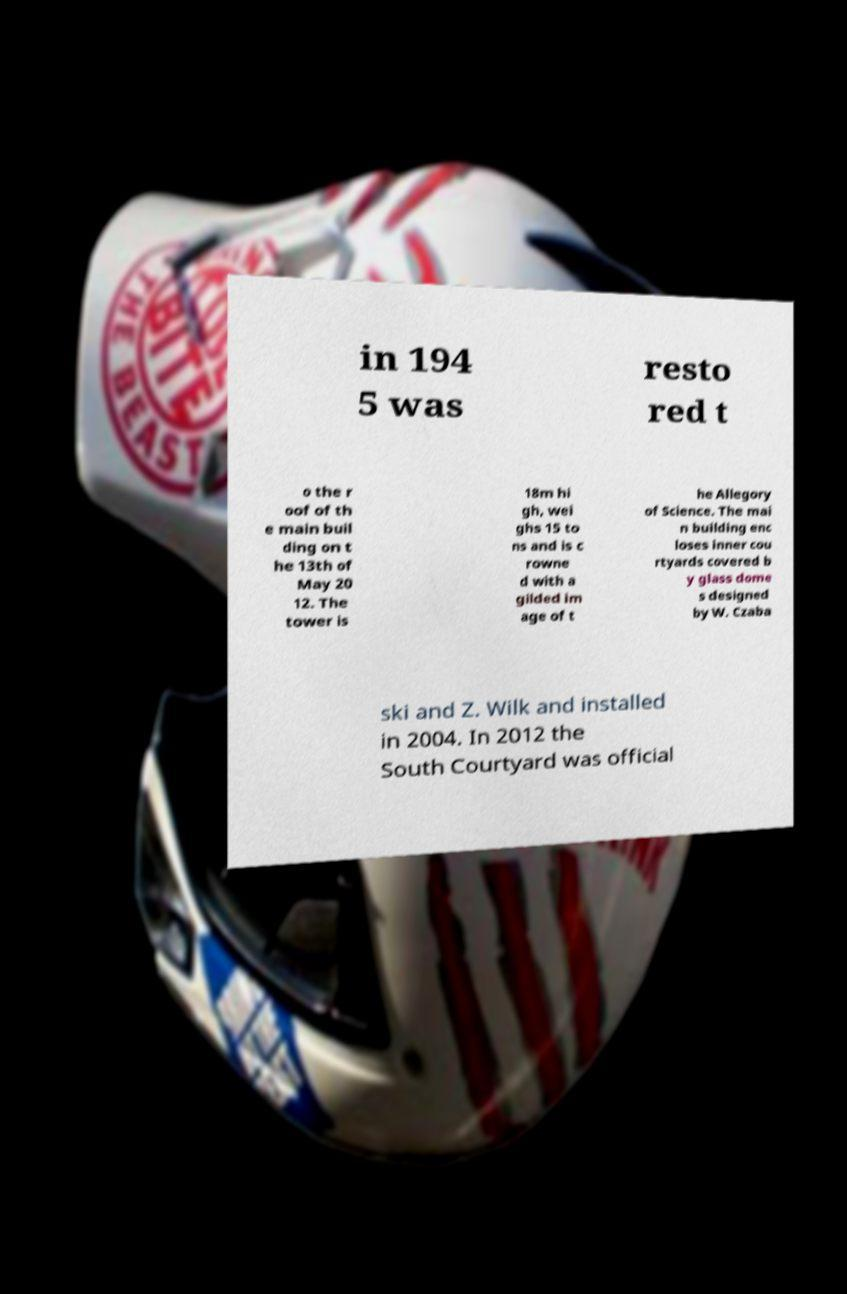I need the written content from this picture converted into text. Can you do that? in 194 5 was resto red t o the r oof of th e main buil ding on t he 13th of May 20 12. The tower is 18m hi gh, wei ghs 15 to ns and is c rowne d with a gilded im age of t he Allegory of Science. The mai n building enc loses inner cou rtyards covered b y glass dome s designed by W. Czaba ski and Z. Wilk and installed in 2004. In 2012 the South Courtyard was official 